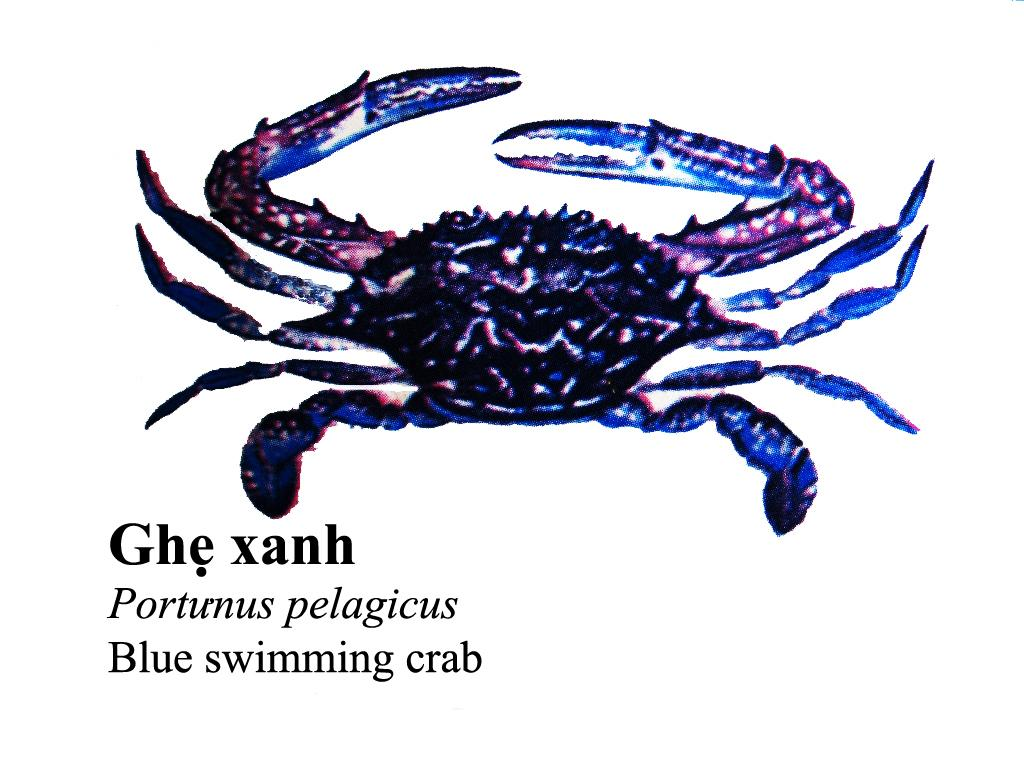What is the main subject of the image? There is a scorpion in the image. What colors can be seen on the scorpion? The scorpion has blue, pink, and black colors. What color is the background of the image? The background of the image is white. What type of canvas is the scorpion painted on in the image? The image does not depict a painting, and therefore there is no canvas present. Is the scorpion located on a specific page in the image? The image does not depict a book or any pages, so the scorpion is not located on a page. 